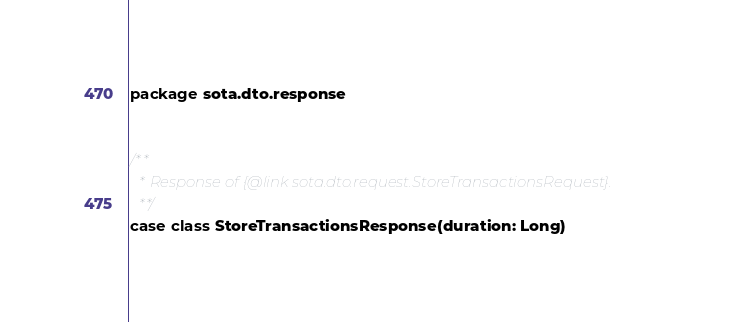<code> <loc_0><loc_0><loc_500><loc_500><_Scala_>package sota.dto.response


/**
  * Response of {@link sota.dto.request.StoreTransactionsRequest}.
  **/
case class StoreTransactionsResponse(duration: Long)
</code> 